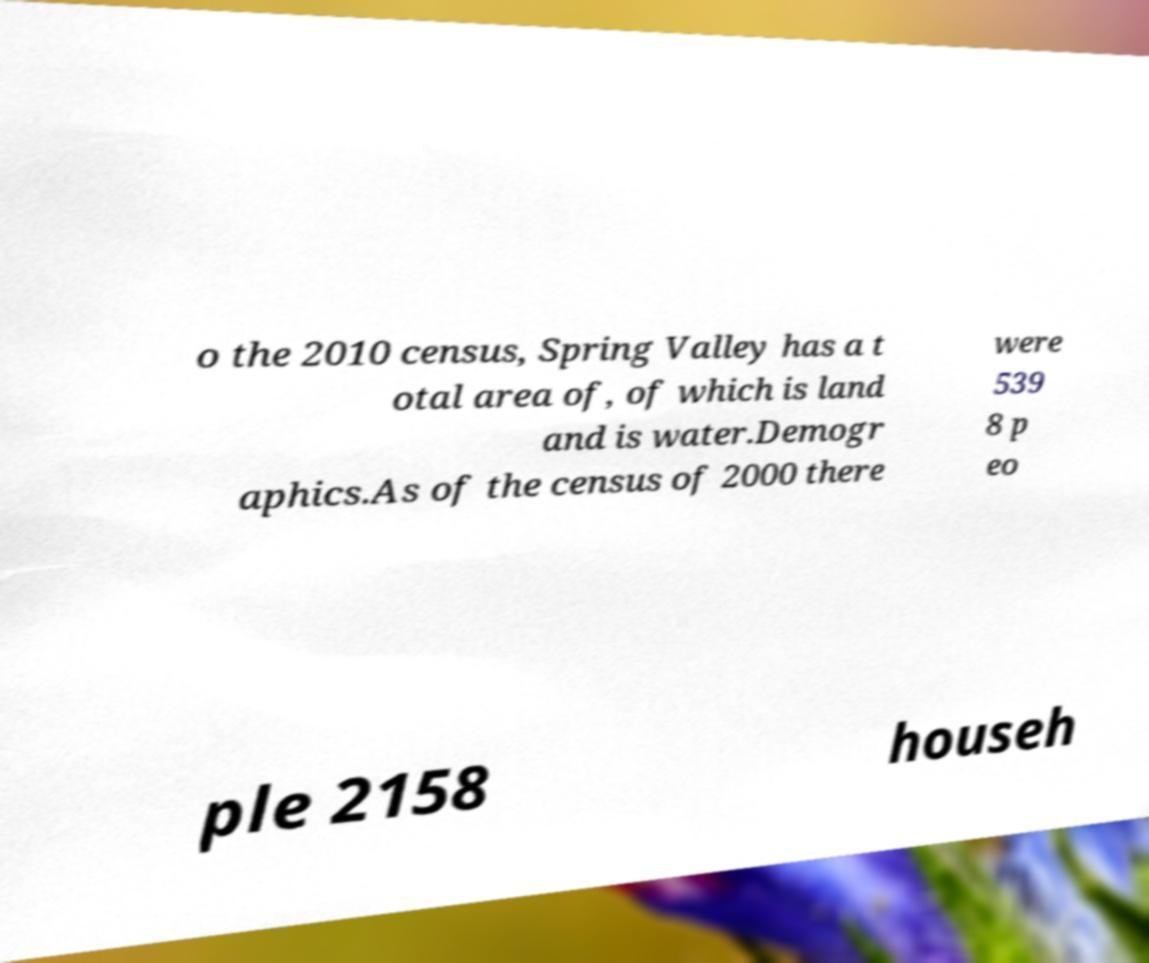Please identify and transcribe the text found in this image. o the 2010 census, Spring Valley has a t otal area of, of which is land and is water.Demogr aphics.As of the census of 2000 there were 539 8 p eo ple 2158 househ 